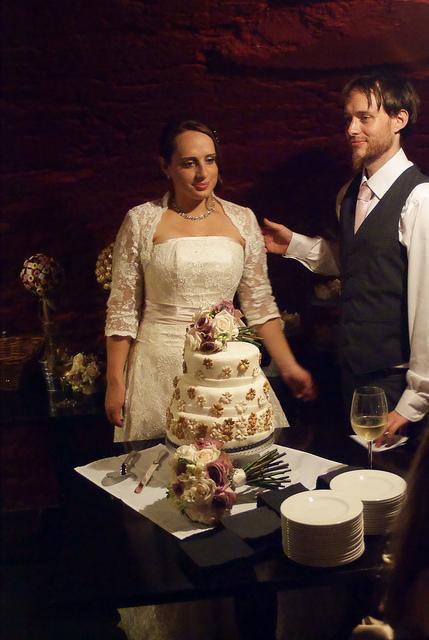How many cakes are there?
Give a very brief answer. 1. How many people are there?
Give a very brief answer. 2. 